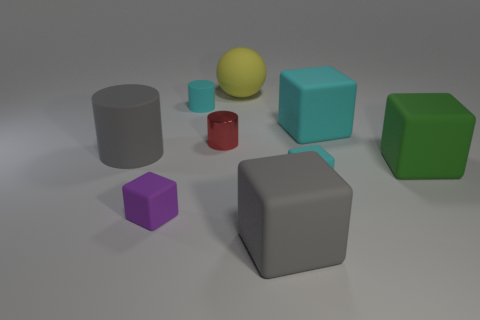Looking at the texture of the objects, how would you describe the lighting and the indications about the material of the objects? The objects exhibit different textures, some with a matte finish and others that appear more reflective, suggesting different materials. The lighting in the scene creates soft shadows and highlights on the objects, hinting at a calm, evenly lit environment possibly indicative of a studio setup. 